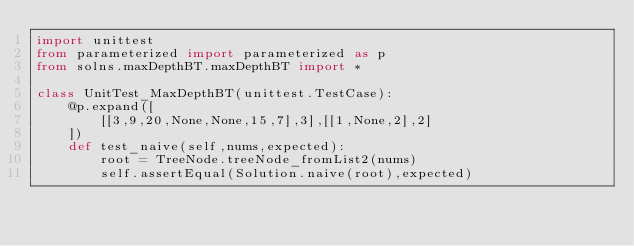<code> <loc_0><loc_0><loc_500><loc_500><_Python_>import unittest
from parameterized import parameterized as p
from solns.maxDepthBT.maxDepthBT import *

class UnitTest_MaxDepthBT(unittest.TestCase):
    @p.expand([
        [[3,9,20,None,None,15,7],3],[[1,None,2],2]
    ])
    def test_naive(self,nums,expected):
        root = TreeNode.treeNode_fromList2(nums)
        self.assertEqual(Solution.naive(root),expected)

</code> 